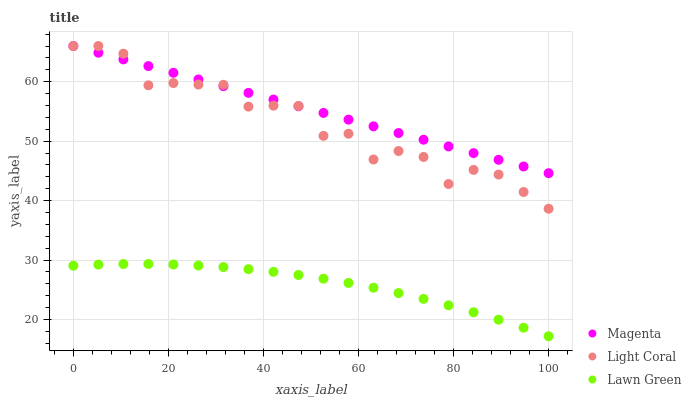Does Lawn Green have the minimum area under the curve?
Answer yes or no. Yes. Does Magenta have the maximum area under the curve?
Answer yes or no. Yes. Does Magenta have the minimum area under the curve?
Answer yes or no. No. Does Lawn Green have the maximum area under the curve?
Answer yes or no. No. Is Magenta the smoothest?
Answer yes or no. Yes. Is Light Coral the roughest?
Answer yes or no. Yes. Is Lawn Green the smoothest?
Answer yes or no. No. Is Lawn Green the roughest?
Answer yes or no. No. Does Lawn Green have the lowest value?
Answer yes or no. Yes. Does Magenta have the lowest value?
Answer yes or no. No. Does Magenta have the highest value?
Answer yes or no. Yes. Does Lawn Green have the highest value?
Answer yes or no. No. Is Lawn Green less than Magenta?
Answer yes or no. Yes. Is Light Coral greater than Lawn Green?
Answer yes or no. Yes. Does Light Coral intersect Magenta?
Answer yes or no. Yes. Is Light Coral less than Magenta?
Answer yes or no. No. Is Light Coral greater than Magenta?
Answer yes or no. No. Does Lawn Green intersect Magenta?
Answer yes or no. No. 